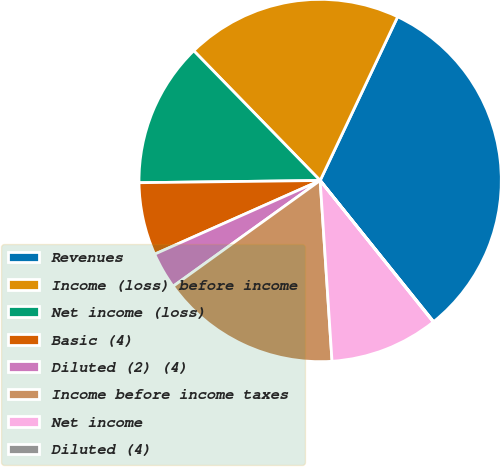<chart> <loc_0><loc_0><loc_500><loc_500><pie_chart><fcel>Revenues<fcel>Income (loss) before income<fcel>Net income (loss)<fcel>Basic (4)<fcel>Diluted (2) (4)<fcel>Income before income taxes<fcel>Net income<fcel>Diluted (4)<nl><fcel>32.19%<fcel>19.33%<fcel>12.9%<fcel>6.47%<fcel>3.26%<fcel>16.12%<fcel>9.69%<fcel>0.04%<nl></chart> 